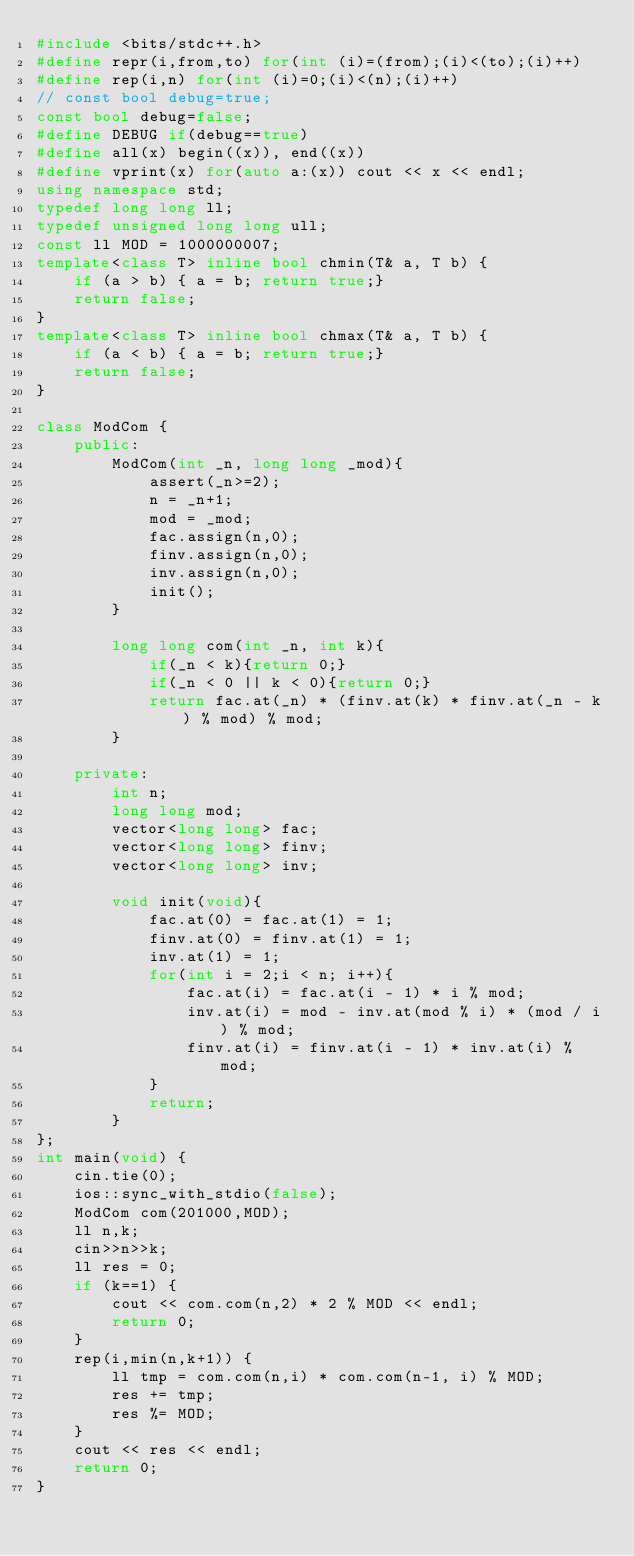<code> <loc_0><loc_0><loc_500><loc_500><_C++_>#include <bits/stdc++.h>
#define repr(i,from,to) for(int (i)=(from);(i)<(to);(i)++)
#define rep(i,n) for(int (i)=0;(i)<(n);(i)++)
// const bool debug=true;
const bool debug=false;
#define DEBUG if(debug==true)
#define all(x) begin((x)), end((x))
#define vprint(x) for(auto a:(x)) cout << x << endl;
using namespace std;
typedef long long ll;
typedef unsigned long long ull;
const ll MOD = 1000000007;
template<class T> inline bool chmin(T& a, T b) {
    if (a > b) { a = b; return true;}
    return false;
}
template<class T> inline bool chmax(T& a, T b) {
    if (a < b) { a = b; return true;}
    return false;
}

class ModCom {
    public:
        ModCom(int _n, long long _mod){
            assert(_n>=2);
            n = _n+1;
            mod = _mod;
            fac.assign(n,0);
            finv.assign(n,0);
            inv.assign(n,0);
            init();
        }

        long long com(int _n, int k){
            if(_n < k){return 0;}
            if(_n < 0 || k < 0){return 0;}
            return fac.at(_n) * (finv.at(k) * finv.at(_n - k) % mod) % mod;
        }

    private:
        int n;
        long long mod;
        vector<long long> fac;
        vector<long long> finv;
        vector<long long> inv;

        void init(void){
            fac.at(0) = fac.at(1) = 1;
            finv.at(0) = finv.at(1) = 1;
            inv.at(1) = 1;
            for(int i = 2;i < n; i++){
                fac.at(i) = fac.at(i - 1) * i % mod;
                inv.at(i) = mod - inv.at(mod % i) * (mod / i) % mod;
                finv.at(i) = finv.at(i - 1) * inv.at(i) % mod;
            }
            return;
        }
};
int main(void) {
    cin.tie(0);
    ios::sync_with_stdio(false);
    ModCom com(201000,MOD);
    ll n,k;
    cin>>n>>k;
    ll res = 0;
    if (k==1) {
        cout << com.com(n,2) * 2 % MOD << endl;
        return 0;
    }
    rep(i,min(n,k+1)) {
        ll tmp = com.com(n,i) * com.com(n-1, i) % MOD;
        res += tmp;
        res %= MOD;
    }
    cout << res << endl;
    return 0;
}
</code> 